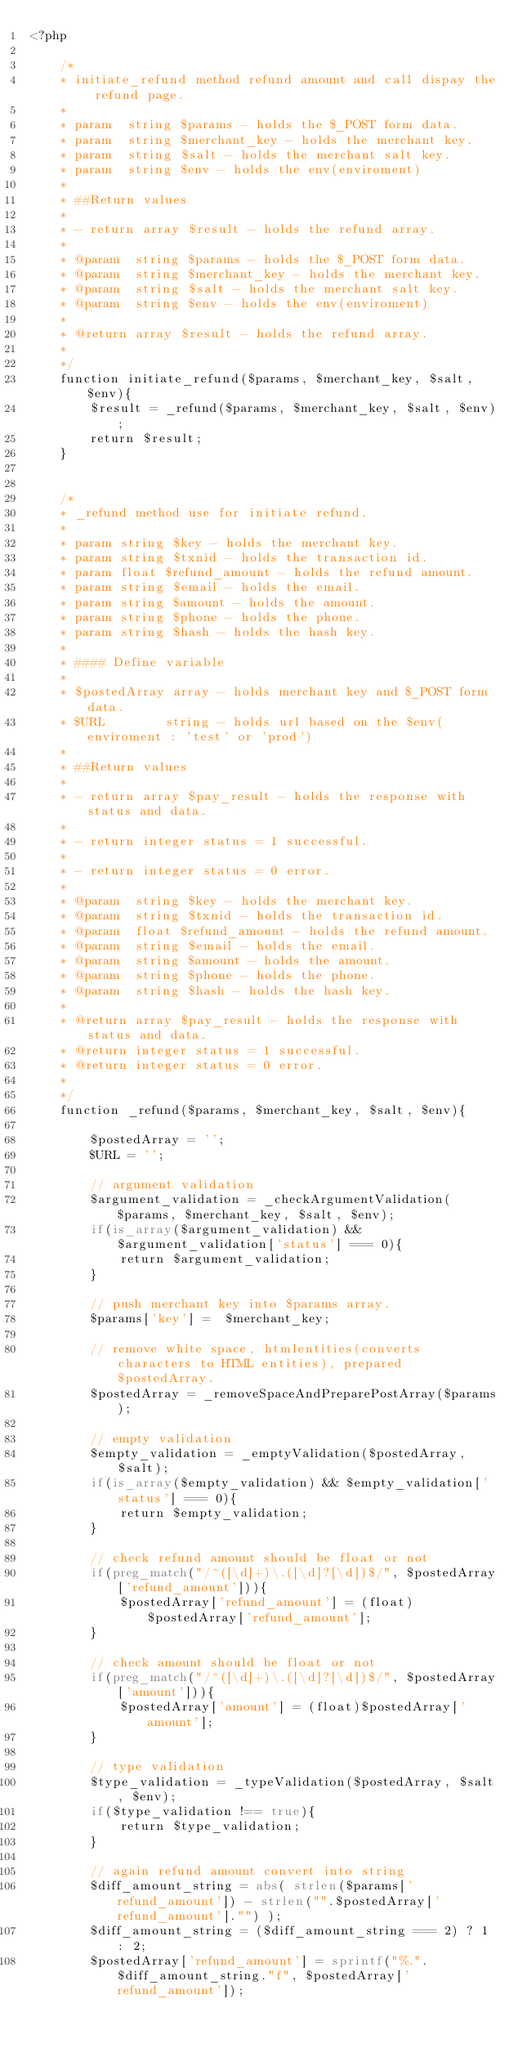Convert code to text. <code><loc_0><loc_0><loc_500><loc_500><_PHP_><?php

    /*
    * initiate_refund method refund amount and call dispay the refund page.
    *
    * param  string $params - holds the $_POST form data.
    * param  string $merchant_key - holds the merchant key.
    * param  string $salt - holds the merchant salt key.
    * param  string $env - holds the env(enviroment)
    *
    * ##Return values
    *
    * - return array $result - holds the refund array.
    *
    * @param  string $params - holds the $_POST form data.
    * @param  string $merchant_key - holds the merchant key.
    * @param  string $salt - holds the merchant salt key.
    * @param  string $env - holds the env(enviroment)
    *
    * @return array $result - holds the refund array.
    *
    */
    function initiate_refund($params, $merchant_key, $salt, $env){
        $result = _refund($params, $merchant_key, $salt, $env);
        return $result;
    }


    /*
    * _refund method use for initiate refund.
    * 
    * param string $key - holds the merchant key.
    * param string $txnid - holds the transaction id.
    * param float $refund_amount - holds the refund amount.
    * param string $email - holds the email.
    * param string $amount - holds the amount.
    * param string $phone - holds the phone.
    * param string $hash - holds the hash key. 
    *
    * #### Define variable
    *  
    * $postedArray array - holds merchant key and $_POST form data.
    * $URL        string - holds url based on the $env(enviroment : 'test' or 'prod')
    *
    * ##Return values
    *
    * - return array $pay_result - holds the response with status and data.
    *
    * - return integer status = 1 successful.
    *
    * - return integer status = 0 error.
    *
    * @param  string $key - holds the merchant key.
    * @param  string $txnid - holds the transaction id.
    * @param  float $refund_amount - holds the refund amount. 
    * @param  string $email - holds the email.
    * @param  string $amount - holds the amount.
    * @param  string $phone - holds the phone.
    * @param  string $hash - holds the hash key. 
    *
    * @return array $pay_result - holds the response with status and data.
    * @return integer status = 1 successful.
    * @return integer status = 0 error.
    *
    */
    function _refund($params, $merchant_key, $salt, $env){

        $postedArray = '';
        $URL = '';

        // argument validation
        $argument_validation = _checkArgumentValidation($params, $merchant_key, $salt, $env);
        if(is_array($argument_validation) && $argument_validation['status'] === 0){
            return $argument_validation;
        }

        // push merchant key into $params array.
        $params['key'] =  $merchant_key;

        // remove white space, htmlentities(converts characters to HTML entities), prepared $postedArray.
        $postedArray = _removeSpaceAndPreparePostArray($params);

        // empty validation
        $empty_validation = _emptyValidation($postedArray, $salt);
        if(is_array($empty_validation) && $empty_validation['status'] === 0){
            return $empty_validation;
        }

        // check refund amount should be float or not 
        if(preg_match("/^([\d]+)\.([\d]?[\d])$/", $postedArray['refund_amount'])){
            $postedArray['refund_amount'] = (float)$postedArray['refund_amount'];
        }

        // check amount should be float or not 
        if(preg_match("/^([\d]+)\.([\d]?[\d])$/", $postedArray['amount'])){
            $postedArray['amount'] = (float)$postedArray['amount'];
        }

        // type validation
        $type_validation = _typeValidation($postedArray, $salt, $env);
        if($type_validation !== true){
            return $type_validation;
        }

        // again refund amount convert into string
        $diff_amount_string = abs( strlen($params['refund_amount']) - strlen("".$postedArray['refund_amount']."") );
        $diff_amount_string = ($diff_amount_string === 2) ? 1 : 2;
        $postedArray['refund_amount'] = sprintf("%.".$diff_amount_string."f", $postedArray['refund_amount']);
</code> 